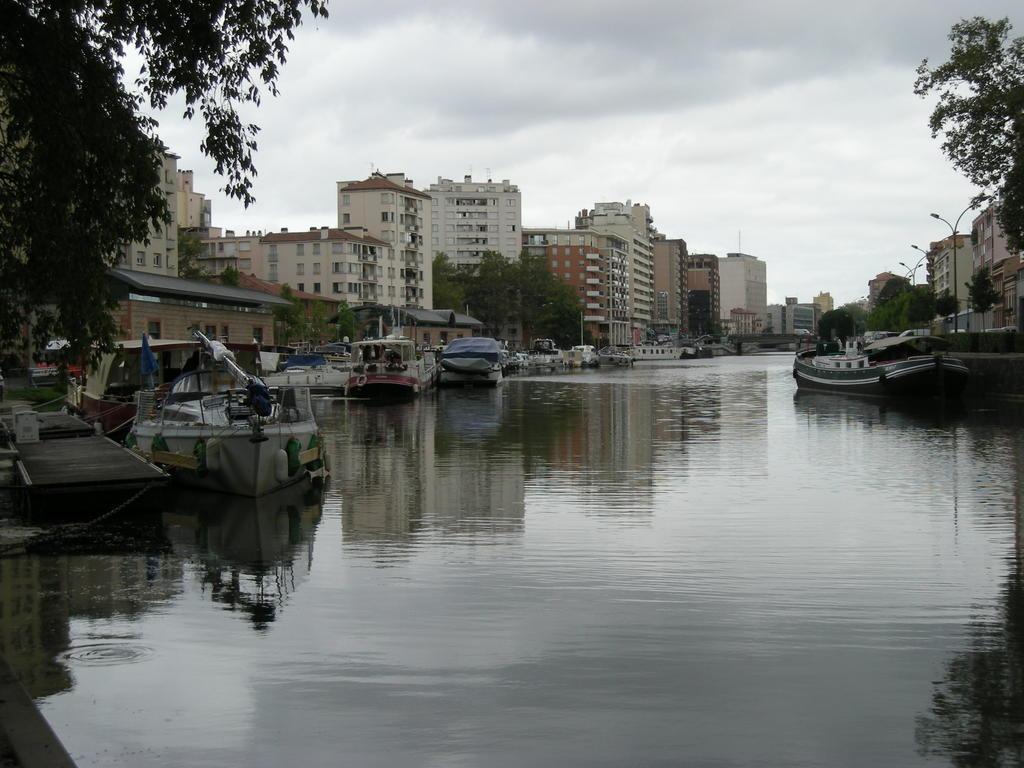Can you describe this image briefly? In this image we can see a few boats on the water, there are some buildings, trees, poles and lights, in the background we can see the sky. 